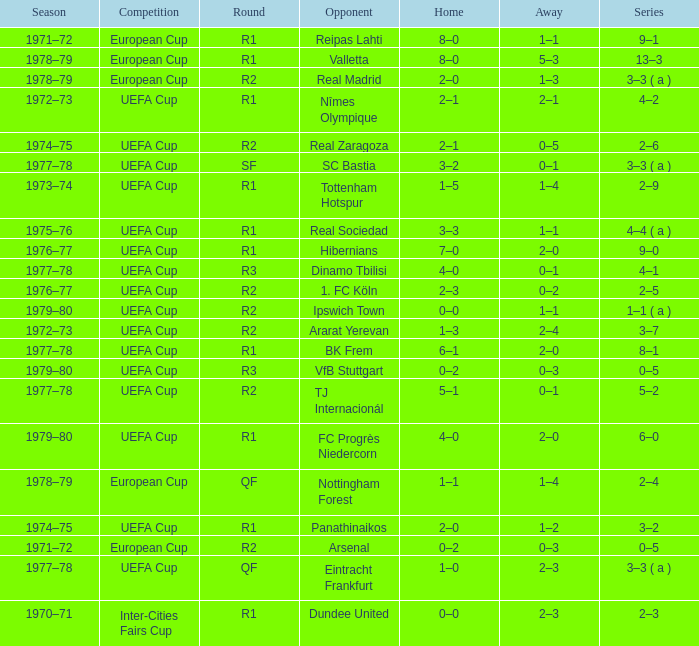Which Series has a Home of 2–0, and an Opponent of panathinaikos? 3–2. 